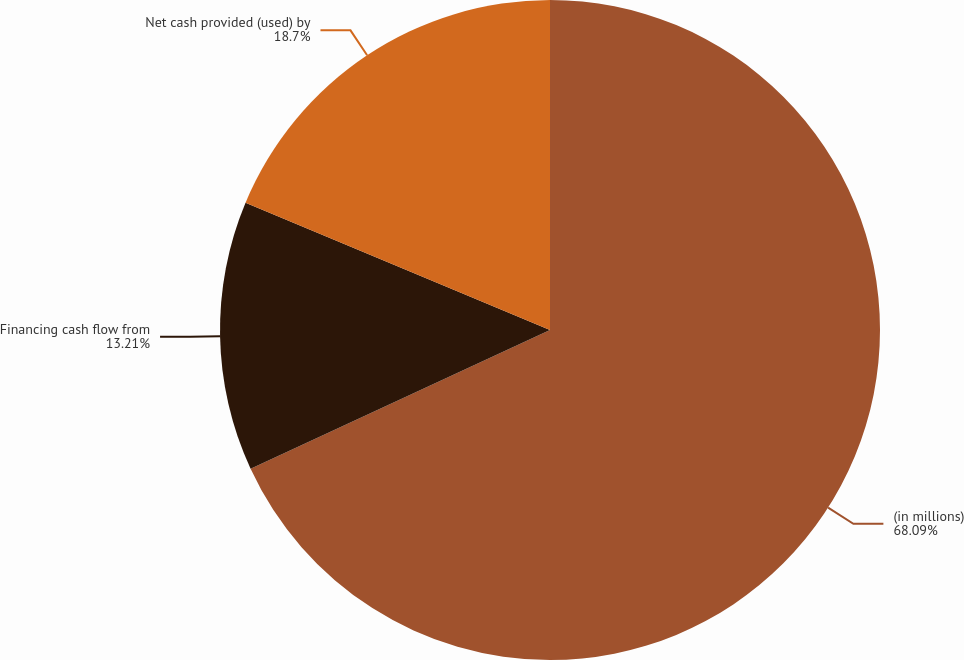Convert chart. <chart><loc_0><loc_0><loc_500><loc_500><pie_chart><fcel>(in millions)<fcel>Financing cash flow from<fcel>Net cash provided (used) by<nl><fcel>68.1%<fcel>13.21%<fcel>18.7%<nl></chart> 